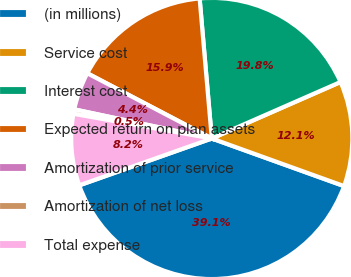<chart> <loc_0><loc_0><loc_500><loc_500><pie_chart><fcel>(in millions)<fcel>Service cost<fcel>Interest cost<fcel>Expected return on plan assets<fcel>Amortization of prior service<fcel>Amortization of net loss<fcel>Total expense<nl><fcel>39.09%<fcel>12.08%<fcel>19.8%<fcel>15.94%<fcel>4.36%<fcel>0.51%<fcel>8.22%<nl></chart> 